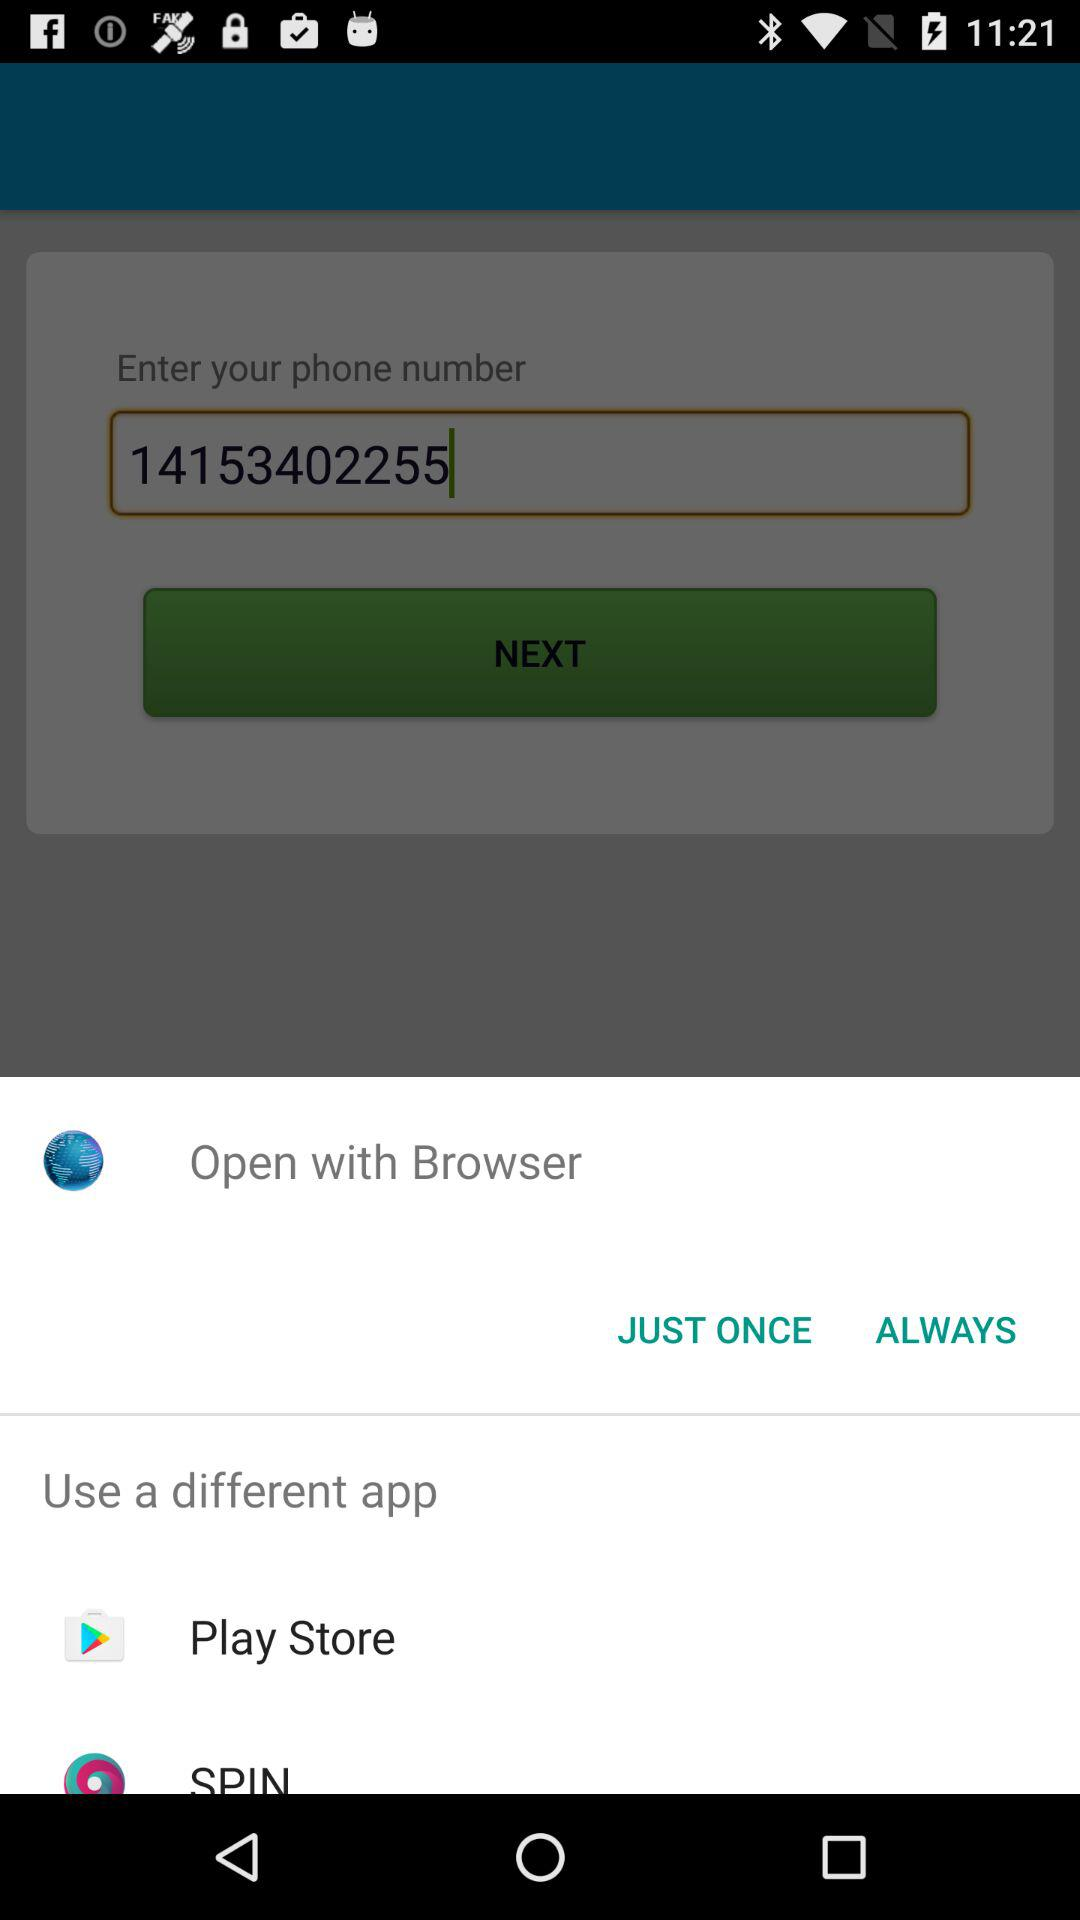Through which application can be open? You can open it through "Browser", "Play Store" and "SPIN". 